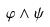Convert formula to latex. <formula><loc_0><loc_0><loc_500><loc_500>\varphi \wedge \psi</formula> 